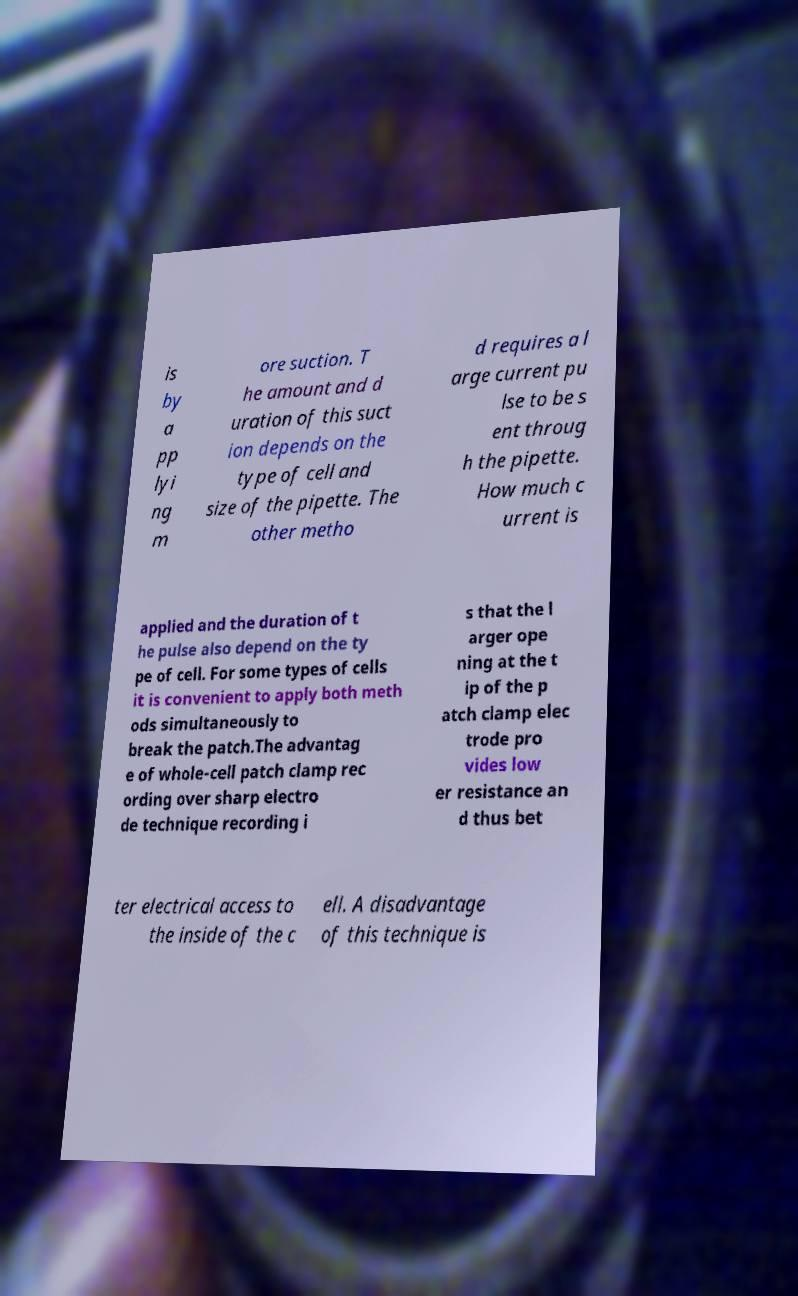Can you read and provide the text displayed in the image?This photo seems to have some interesting text. Can you extract and type it out for me? is by a pp lyi ng m ore suction. T he amount and d uration of this suct ion depends on the type of cell and size of the pipette. The other metho d requires a l arge current pu lse to be s ent throug h the pipette. How much c urrent is applied and the duration of t he pulse also depend on the ty pe of cell. For some types of cells it is convenient to apply both meth ods simultaneously to break the patch.The advantag e of whole-cell patch clamp rec ording over sharp electro de technique recording i s that the l arger ope ning at the t ip of the p atch clamp elec trode pro vides low er resistance an d thus bet ter electrical access to the inside of the c ell. A disadvantage of this technique is 